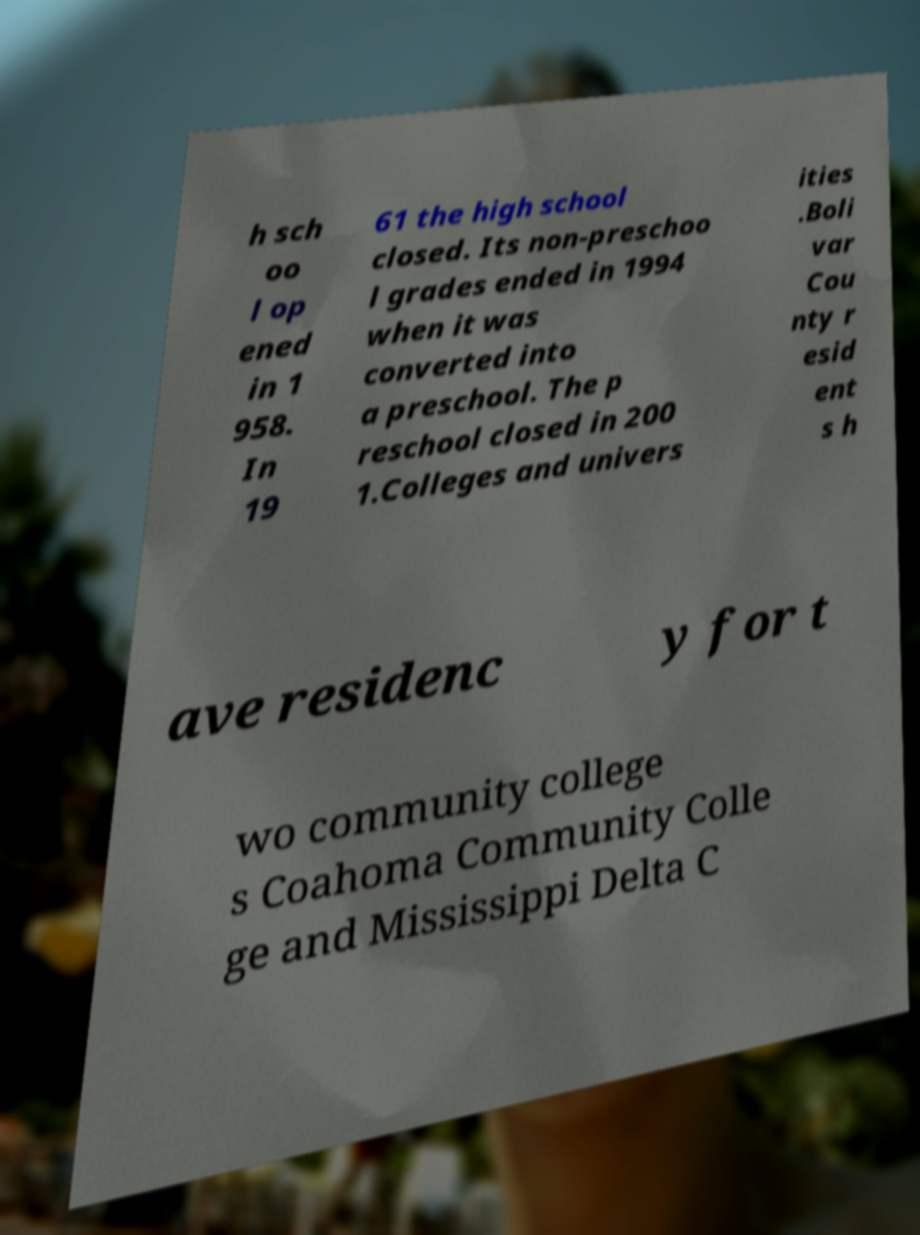Can you read and provide the text displayed in the image?This photo seems to have some interesting text. Can you extract and type it out for me? h sch oo l op ened in 1 958. In 19 61 the high school closed. Its non-preschoo l grades ended in 1994 when it was converted into a preschool. The p reschool closed in 200 1.Colleges and univers ities .Boli var Cou nty r esid ent s h ave residenc y for t wo community college s Coahoma Community Colle ge and Mississippi Delta C 